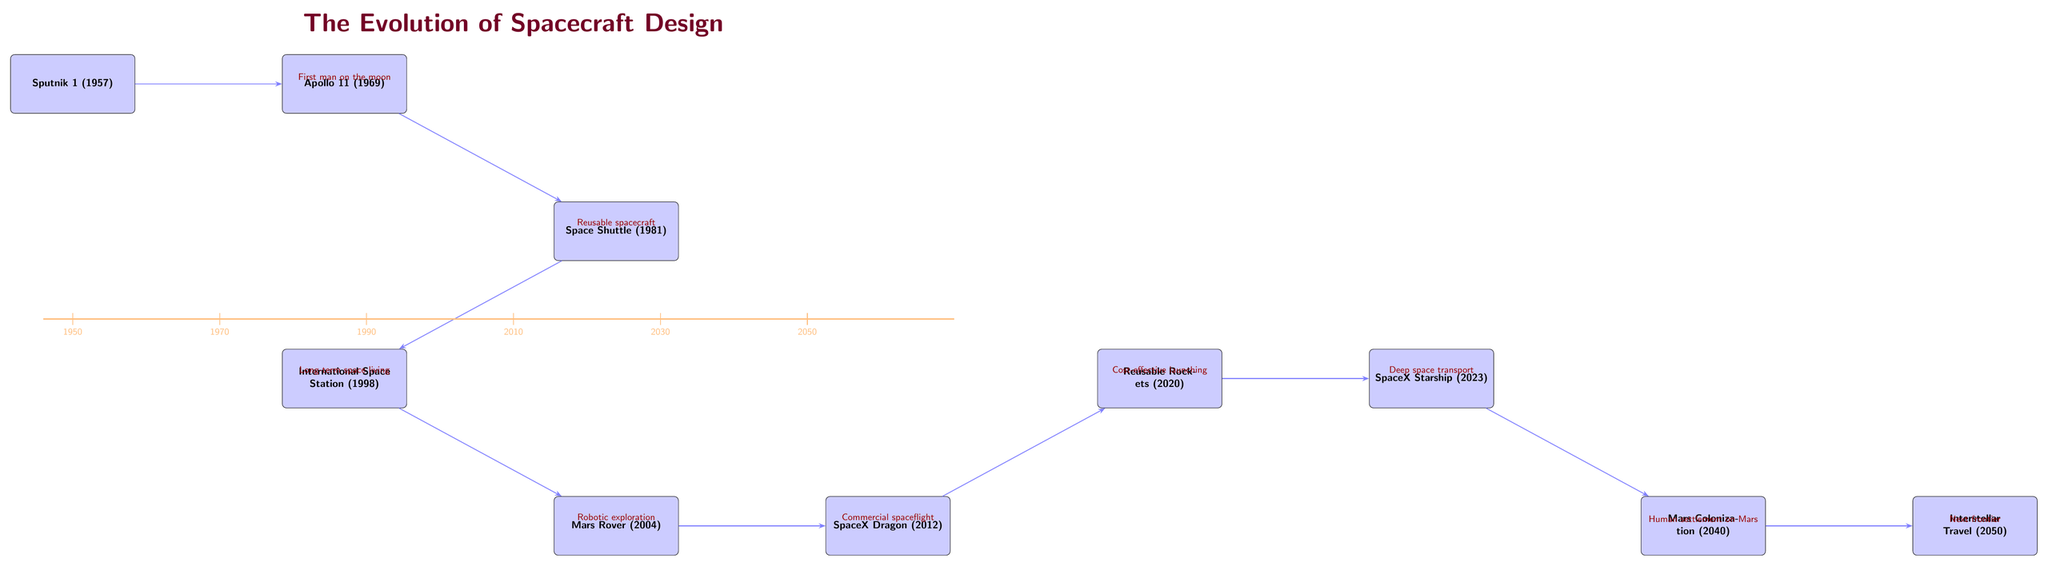What is the first spacecraft listed in the diagram? The diagram shows "Sputnik 1" as the first event node at the top left corner.
Answer: Sputnik 1 How many major milestones are depicted in the diagram? By counting each event node in the diagram, there are ten major milestones from Sputnik 1 to Interstellar Travel (2050).
Answer: 10 What year is associated with the Apollo 11 spacecraft? The Apollo 11 spacecraft is shown in the diagram at the year 1969, identified directly next to its label.
Answer: 1969 Which event follows the Mars Rover in the timeline? From the diagram, the event that follows the Mars Rover is the Dragon (SpaceX Dragon), which is positioned directly to the right of it.
Answer: SpaceX Dragon What technology is related to the "Reusable Rockets" node? The diagram indicates that "Cost-effective launching" is the relationship connecting "Dragon" to "Reusable Rockets," pointing to a technological advancement in spaceflight.
Answer: Cost-effective launching What is the relationship between "Starship" and "Mars Colonization"? The diagram states that the relationship is "Human settlement on Mars," indicating the purpose that follows the development of the Starship spacecraft.
Answer: Human settlement on Mars Which event is associated with the year 2040? In the diagram, "Mars Colonization" is placed in the year 2040, marked directly beneath the respective label.
Answer: Mars Colonization How does "International Space Station" relate to "Mars Rover"? The diagram indicates that the relationship is "Robotic exploration," which flows from the ISS down to the Mars Rover, showcasing a progressive advancement in space technology.
Answer: Robotic exploration In which year was the Space Shuttle launched? Space Shuttle is positioned in the diagram specifically in the year 1981, marked alongside its event label.
Answer: 1981 